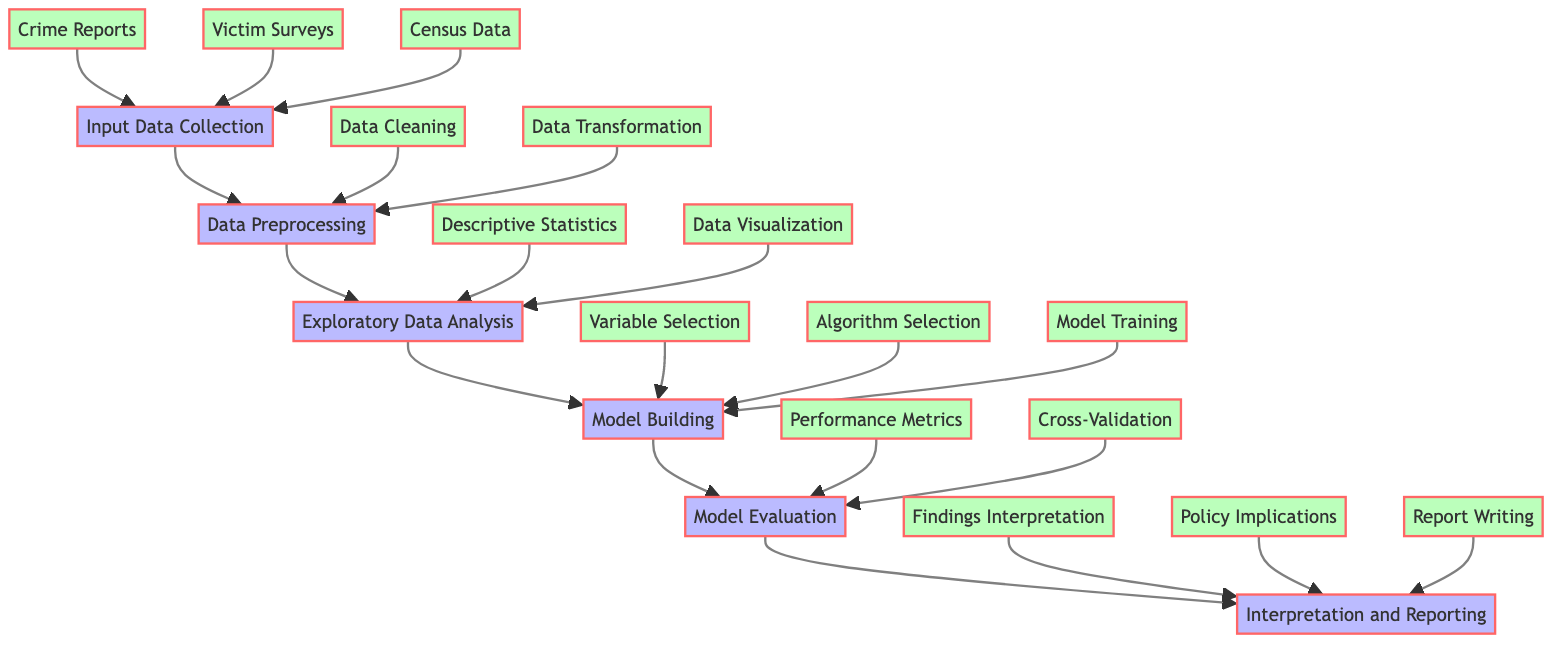What are the three sources of input data collection? The diagram lists three sources under the "Input Data Collection" node: Crime Reports, Victim Surveys, and Census Data.
Answer: Crime Reports, Victim Surveys, Census Data What steps are involved in data preprocessing? From the "Data Preprocessing" node, there are two main steps: Data Cleaning and Data Transformation. These are the components shown directly under this node.
Answer: Data Cleaning, Data Transformation How many nodes are present in the "Model Evaluation" phase? The "Model Evaluation" phase has two components listed: Performance Metrics and Cross-Validation. Counting these gives two nodes in this section.
Answer: 2 What is the final step in the workflow according to the diagram? The diagram shows that the last process in the workflow is "Interpretation and Reporting," as indicated at the end of the flow.
Answer: Interpretation and Reporting Which preprocessing step involves correcting inconsistent entries? The preprocessing step that involves correcting inconsistent entries is "Data Cleaning," which is mentioned directly under the Data Preprocessing node.
Answer: Data Cleaning How is exploratory data analysis related to model building? The "Exploratory Data Analysis" node flows into the "Model Building" node, indicating that the analysis done in EDA informs and precedes the building of models. This relationship shows a progression from understanding data to applying models.
Answer: Exploratory Data Analysis informs Model Building What type of data visualization is included in exploratory data analysis? The diagram specifies "Data Visualization" as one of the main tasks in the EDA section, which includes visual tools such as bar charts, histograms, and heatmaps to identify patterns and trends.
Answer: Data Visualization What are the two performance metrics mentioned for model evaluation? The "Model Evaluation" node includes two specific performance metrics: Accuracy and Precision, along with Recall and F1 score, but for this question only the first two are necessary.
Answer: Accuracy, Precision What is documented in the report writing step? The last step in the workflow specifically mentions that "Report Writing" involves documenting the methodology, analysis, findings, and recommendations. This encompasses the entirety of what is included in that documentation.
Answer: Methodology, analysis, findings, recommendations 